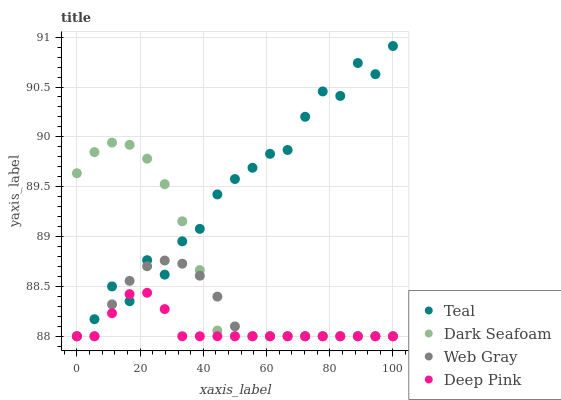Does Deep Pink have the minimum area under the curve?
Answer yes or no. Yes. Does Teal have the maximum area under the curve?
Answer yes or no. Yes. Does Web Gray have the minimum area under the curve?
Answer yes or no. No. Does Web Gray have the maximum area under the curve?
Answer yes or no. No. Is Deep Pink the smoothest?
Answer yes or no. Yes. Is Teal the roughest?
Answer yes or no. Yes. Is Web Gray the smoothest?
Answer yes or no. No. Is Web Gray the roughest?
Answer yes or no. No. Does Dark Seafoam have the lowest value?
Answer yes or no. Yes. Does Teal have the highest value?
Answer yes or no. Yes. Does Web Gray have the highest value?
Answer yes or no. No. Does Dark Seafoam intersect Web Gray?
Answer yes or no. Yes. Is Dark Seafoam less than Web Gray?
Answer yes or no. No. Is Dark Seafoam greater than Web Gray?
Answer yes or no. No. 